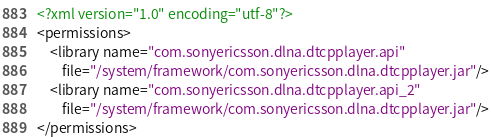Convert code to text. <code><loc_0><loc_0><loc_500><loc_500><_XML_><?xml version="1.0" encoding="utf-8"?>
<permissions>
    <library name="com.sonyericsson.dlna.dtcpplayer.api"
        file="/system/framework/com.sonyericsson.dlna.dtcpplayer.jar"/>
    <library name="com.sonyericsson.dlna.dtcpplayer.api_2"
        file="/system/framework/com.sonyericsson.dlna.dtcpplayer.jar"/>
</permissions>
</code> 